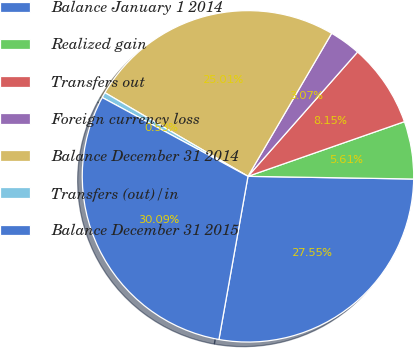<chart> <loc_0><loc_0><loc_500><loc_500><pie_chart><fcel>Balance January 1 2014<fcel>Realized gain<fcel>Transfers out<fcel>Foreign currency loss<fcel>Balance December 31 2014<fcel>Transfers (out)/in<fcel>Balance December 31 2015<nl><fcel>27.54%<fcel>5.61%<fcel>8.15%<fcel>3.07%<fcel>25.0%<fcel>0.53%<fcel>30.08%<nl></chart> 